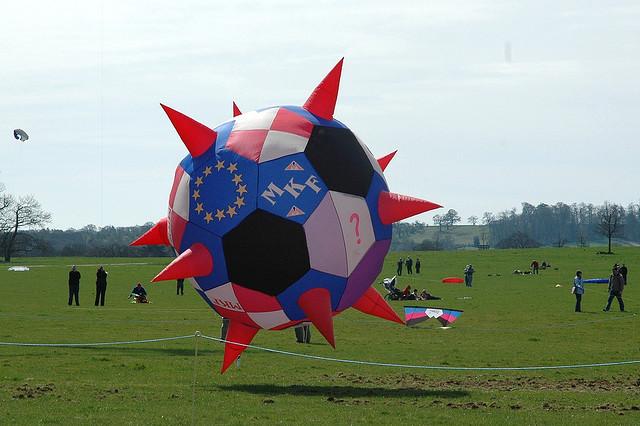What color is the grass?
Short answer required. Green. Where is the ball?
Give a very brief answer. Outside. Would you say this ball is small?
Give a very brief answer. No. 